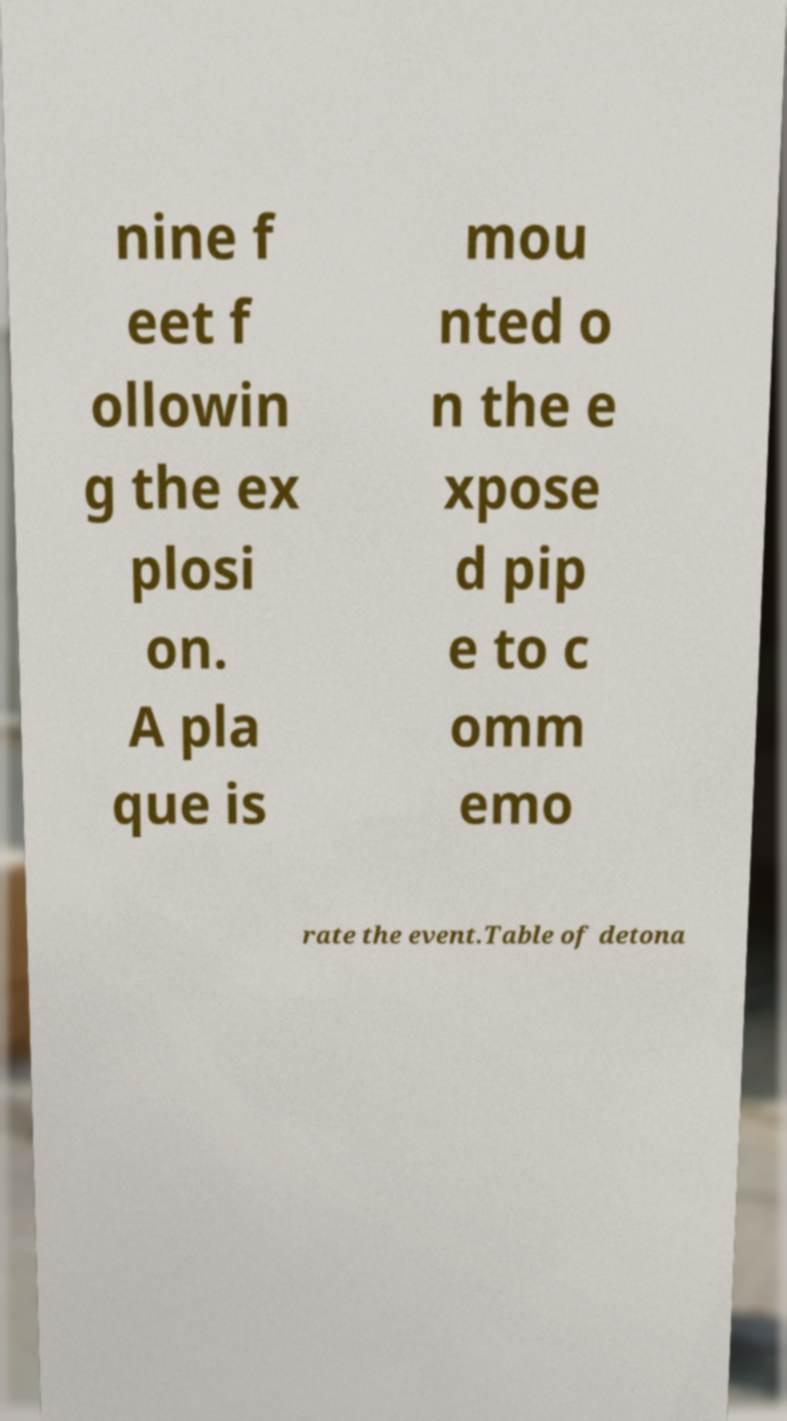Please identify and transcribe the text found in this image. nine f eet f ollowin g the ex plosi on. A pla que is mou nted o n the e xpose d pip e to c omm emo rate the event.Table of detona 